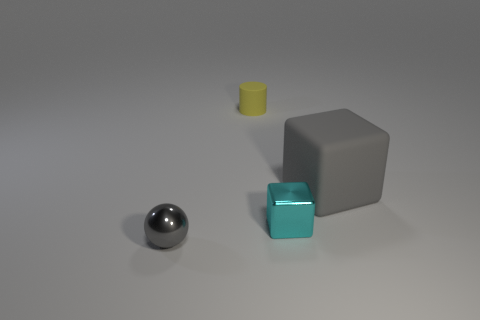There is a object that is the same color as the big rubber cube; what is its size?
Your answer should be compact. Small. The tiny rubber cylinder is what color?
Your answer should be compact. Yellow. There is a large block; are there any matte blocks to the right of it?
Offer a very short reply. No. Does the cyan metallic thing have the same shape as the big object that is behind the cyan metallic cube?
Offer a very short reply. Yes. How many other things are the same material as the yellow cylinder?
Ensure brevity in your answer.  1. What color is the tiny metal thing in front of the metal object on the right side of the gray object in front of the large block?
Provide a succinct answer. Gray. There is a rubber thing to the right of the metallic object to the right of the tiny cylinder; what shape is it?
Your response must be concise. Cube. Is the number of small yellow rubber things that are behind the cyan thing greater than the number of large yellow metal cylinders?
Your response must be concise. Yes. Does the metal object to the right of the cylinder have the same shape as the gray matte thing?
Give a very brief answer. Yes. Is there another cyan thing of the same shape as the big matte object?
Your answer should be compact. Yes. 